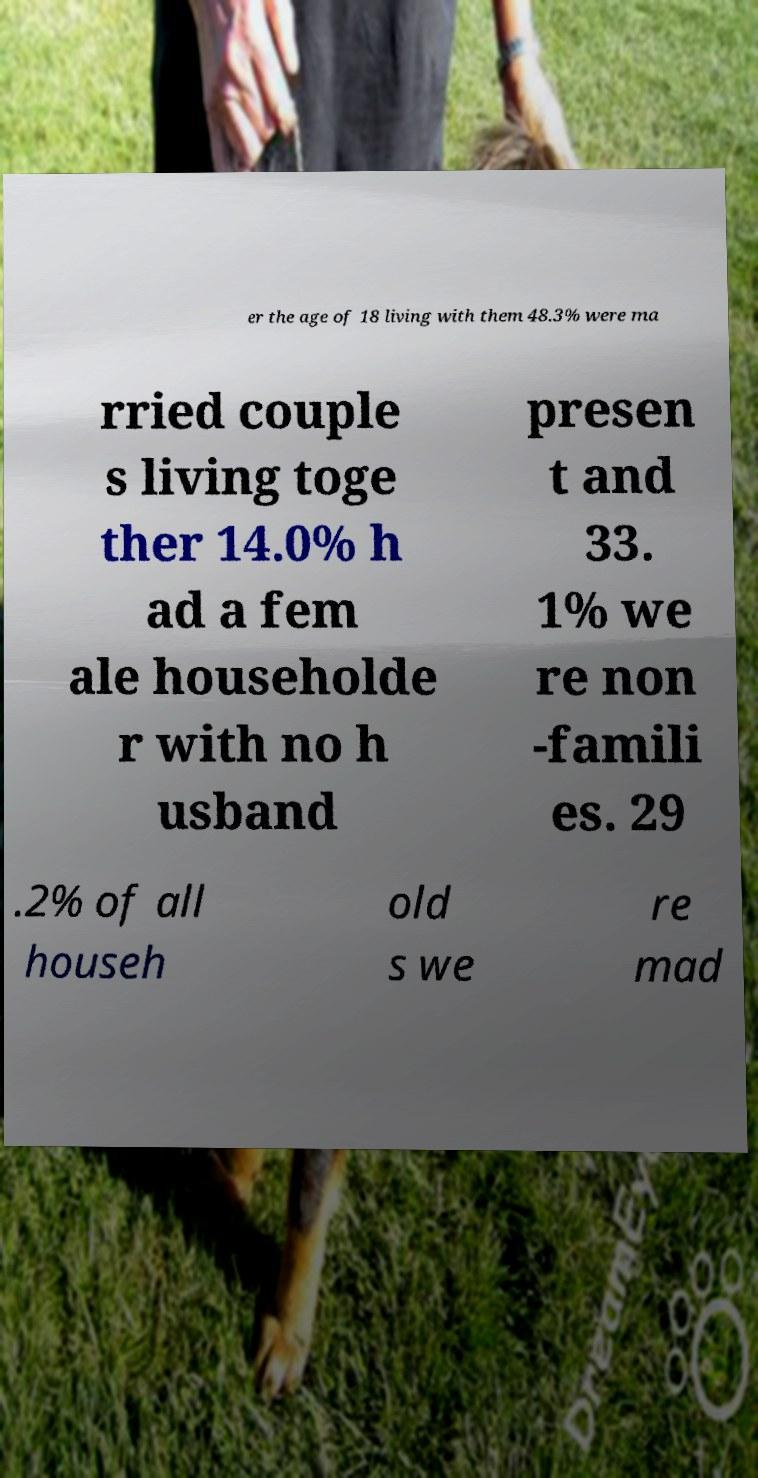Could you extract and type out the text from this image? er the age of 18 living with them 48.3% were ma rried couple s living toge ther 14.0% h ad a fem ale householde r with no h usband presen t and 33. 1% we re non -famili es. 29 .2% of all househ old s we re mad 